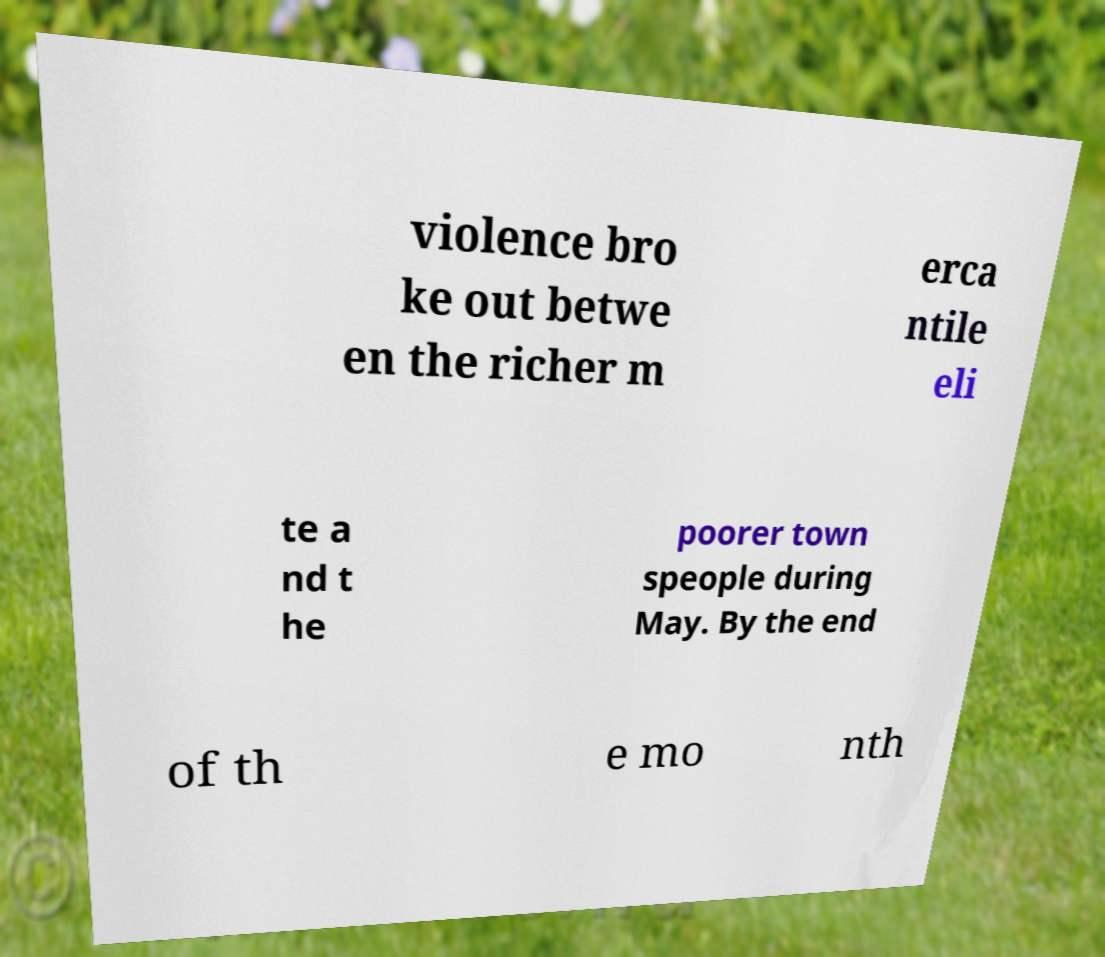Please read and relay the text visible in this image. What does it say? violence bro ke out betwe en the richer m erca ntile eli te a nd t he poorer town speople during May. By the end of th e mo nth 